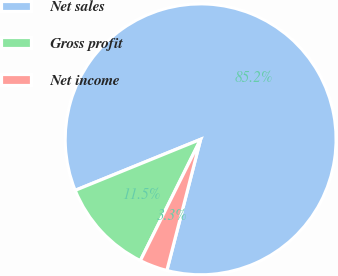<chart> <loc_0><loc_0><loc_500><loc_500><pie_chart><fcel>Net sales<fcel>Gross profit<fcel>Net income<nl><fcel>85.16%<fcel>11.51%<fcel>3.33%<nl></chart> 